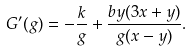<formula> <loc_0><loc_0><loc_500><loc_500>G ^ { \prime } ( g ) = - \frac { k } { g } + \frac { b y ( 3 x + y ) } { g ( x - y ) } .</formula> 